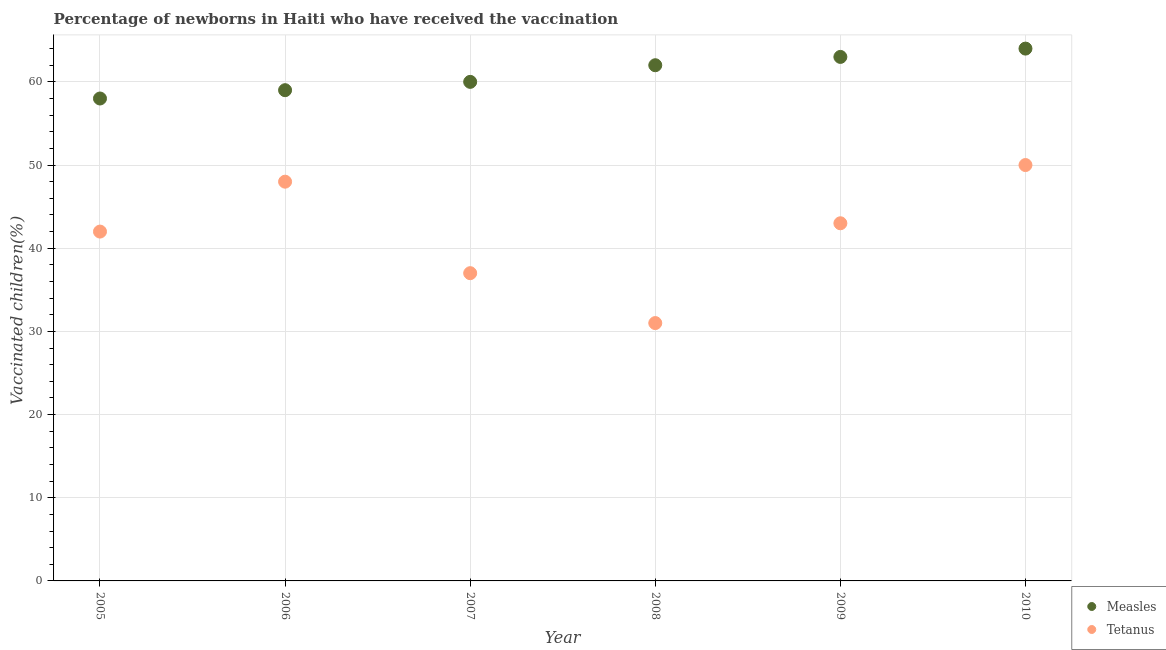How many different coloured dotlines are there?
Provide a short and direct response. 2. What is the percentage of newborns who received vaccination for tetanus in 2009?
Your answer should be very brief. 43. Across all years, what is the maximum percentage of newborns who received vaccination for measles?
Provide a short and direct response. 64. Across all years, what is the minimum percentage of newborns who received vaccination for measles?
Make the answer very short. 58. In which year was the percentage of newborns who received vaccination for measles maximum?
Make the answer very short. 2010. In which year was the percentage of newborns who received vaccination for tetanus minimum?
Offer a very short reply. 2008. What is the total percentage of newborns who received vaccination for tetanus in the graph?
Offer a terse response. 251. What is the difference between the percentage of newborns who received vaccination for measles in 2005 and that in 2009?
Provide a succinct answer. -5. What is the difference between the percentage of newborns who received vaccination for measles in 2010 and the percentage of newborns who received vaccination for tetanus in 2006?
Provide a succinct answer. 16. What is the average percentage of newborns who received vaccination for tetanus per year?
Offer a terse response. 41.83. In the year 2007, what is the difference between the percentage of newborns who received vaccination for tetanus and percentage of newborns who received vaccination for measles?
Offer a very short reply. -23. What is the ratio of the percentage of newborns who received vaccination for measles in 2005 to that in 2008?
Your answer should be very brief. 0.94. Is the percentage of newborns who received vaccination for tetanus in 2007 less than that in 2010?
Your answer should be compact. Yes. What is the difference between the highest and the second highest percentage of newborns who received vaccination for tetanus?
Provide a succinct answer. 2. What is the difference between the highest and the lowest percentage of newborns who received vaccination for tetanus?
Ensure brevity in your answer.  19. In how many years, is the percentage of newborns who received vaccination for tetanus greater than the average percentage of newborns who received vaccination for tetanus taken over all years?
Keep it short and to the point. 4. Is the sum of the percentage of newborns who received vaccination for tetanus in 2006 and 2007 greater than the maximum percentage of newborns who received vaccination for measles across all years?
Offer a terse response. Yes. Is the percentage of newborns who received vaccination for tetanus strictly less than the percentage of newborns who received vaccination for measles over the years?
Provide a succinct answer. Yes. How many dotlines are there?
Your response must be concise. 2. What is the difference between two consecutive major ticks on the Y-axis?
Provide a short and direct response. 10. Are the values on the major ticks of Y-axis written in scientific E-notation?
Provide a succinct answer. No. Does the graph contain grids?
Your answer should be very brief. Yes. How many legend labels are there?
Make the answer very short. 2. How are the legend labels stacked?
Make the answer very short. Vertical. What is the title of the graph?
Make the answer very short. Percentage of newborns in Haiti who have received the vaccination. What is the label or title of the X-axis?
Provide a succinct answer. Year. What is the label or title of the Y-axis?
Make the answer very short. Vaccinated children(%)
. What is the Vaccinated children(%)
 in Measles in 2005?
Give a very brief answer. 58. What is the Vaccinated children(%)
 in Tetanus in 2005?
Your answer should be compact. 42. What is the Vaccinated children(%)
 in Tetanus in 2006?
Your answer should be compact. 48. What is the Vaccinated children(%)
 of Measles in 2007?
Provide a short and direct response. 60. What is the Vaccinated children(%)
 in Tetanus in 2008?
Your answer should be very brief. 31. What is the Vaccinated children(%)
 of Tetanus in 2009?
Your answer should be very brief. 43. What is the Vaccinated children(%)
 of Tetanus in 2010?
Provide a succinct answer. 50. Across all years, what is the maximum Vaccinated children(%)
 in Measles?
Your answer should be compact. 64. What is the total Vaccinated children(%)
 of Measles in the graph?
Your response must be concise. 366. What is the total Vaccinated children(%)
 in Tetanus in the graph?
Keep it short and to the point. 251. What is the difference between the Vaccinated children(%)
 of Measles in 2005 and that in 2007?
Your response must be concise. -2. What is the difference between the Vaccinated children(%)
 in Tetanus in 2005 and that in 2007?
Ensure brevity in your answer.  5. What is the difference between the Vaccinated children(%)
 of Measles in 2005 and that in 2008?
Your answer should be compact. -4. What is the difference between the Vaccinated children(%)
 in Measles in 2005 and that in 2010?
Provide a succinct answer. -6. What is the difference between the Vaccinated children(%)
 in Tetanus in 2005 and that in 2010?
Offer a terse response. -8. What is the difference between the Vaccinated children(%)
 in Measles in 2006 and that in 2008?
Your response must be concise. -3. What is the difference between the Vaccinated children(%)
 in Tetanus in 2006 and that in 2008?
Offer a terse response. 17. What is the difference between the Vaccinated children(%)
 in Measles in 2006 and that in 2009?
Your answer should be compact. -4. What is the difference between the Vaccinated children(%)
 of Tetanus in 2006 and that in 2009?
Your answer should be very brief. 5. What is the difference between the Vaccinated children(%)
 of Measles in 2006 and that in 2010?
Ensure brevity in your answer.  -5. What is the difference between the Vaccinated children(%)
 of Tetanus in 2006 and that in 2010?
Provide a short and direct response. -2. What is the difference between the Vaccinated children(%)
 in Measles in 2007 and that in 2009?
Make the answer very short. -3. What is the difference between the Vaccinated children(%)
 in Tetanus in 2007 and that in 2009?
Provide a short and direct response. -6. What is the difference between the Vaccinated children(%)
 of Tetanus in 2007 and that in 2010?
Make the answer very short. -13. What is the difference between the Vaccinated children(%)
 in Tetanus in 2008 and that in 2010?
Provide a succinct answer. -19. What is the difference between the Vaccinated children(%)
 of Tetanus in 2009 and that in 2010?
Keep it short and to the point. -7. What is the difference between the Vaccinated children(%)
 of Measles in 2005 and the Vaccinated children(%)
 of Tetanus in 2007?
Make the answer very short. 21. What is the difference between the Vaccinated children(%)
 in Measles in 2005 and the Vaccinated children(%)
 in Tetanus in 2008?
Ensure brevity in your answer.  27. What is the difference between the Vaccinated children(%)
 in Measles in 2006 and the Vaccinated children(%)
 in Tetanus in 2007?
Your answer should be very brief. 22. What is the difference between the Vaccinated children(%)
 of Measles in 2007 and the Vaccinated children(%)
 of Tetanus in 2008?
Give a very brief answer. 29. What is the difference between the Vaccinated children(%)
 in Measles in 2007 and the Vaccinated children(%)
 in Tetanus in 2009?
Your answer should be very brief. 17. What is the average Vaccinated children(%)
 of Tetanus per year?
Your answer should be very brief. 41.83. In the year 2006, what is the difference between the Vaccinated children(%)
 in Measles and Vaccinated children(%)
 in Tetanus?
Offer a very short reply. 11. In the year 2007, what is the difference between the Vaccinated children(%)
 of Measles and Vaccinated children(%)
 of Tetanus?
Offer a terse response. 23. What is the ratio of the Vaccinated children(%)
 of Measles in 2005 to that in 2006?
Provide a short and direct response. 0.98. What is the ratio of the Vaccinated children(%)
 in Tetanus in 2005 to that in 2006?
Your answer should be compact. 0.88. What is the ratio of the Vaccinated children(%)
 in Measles in 2005 to that in 2007?
Your answer should be compact. 0.97. What is the ratio of the Vaccinated children(%)
 of Tetanus in 2005 to that in 2007?
Your answer should be compact. 1.14. What is the ratio of the Vaccinated children(%)
 in Measles in 2005 to that in 2008?
Your response must be concise. 0.94. What is the ratio of the Vaccinated children(%)
 of Tetanus in 2005 to that in 2008?
Keep it short and to the point. 1.35. What is the ratio of the Vaccinated children(%)
 in Measles in 2005 to that in 2009?
Provide a succinct answer. 0.92. What is the ratio of the Vaccinated children(%)
 in Tetanus in 2005 to that in 2009?
Give a very brief answer. 0.98. What is the ratio of the Vaccinated children(%)
 in Measles in 2005 to that in 2010?
Offer a terse response. 0.91. What is the ratio of the Vaccinated children(%)
 in Tetanus in 2005 to that in 2010?
Ensure brevity in your answer.  0.84. What is the ratio of the Vaccinated children(%)
 in Measles in 2006 to that in 2007?
Your response must be concise. 0.98. What is the ratio of the Vaccinated children(%)
 of Tetanus in 2006 to that in 2007?
Ensure brevity in your answer.  1.3. What is the ratio of the Vaccinated children(%)
 of Measles in 2006 to that in 2008?
Provide a succinct answer. 0.95. What is the ratio of the Vaccinated children(%)
 of Tetanus in 2006 to that in 2008?
Make the answer very short. 1.55. What is the ratio of the Vaccinated children(%)
 in Measles in 2006 to that in 2009?
Your response must be concise. 0.94. What is the ratio of the Vaccinated children(%)
 in Tetanus in 2006 to that in 2009?
Ensure brevity in your answer.  1.12. What is the ratio of the Vaccinated children(%)
 in Measles in 2006 to that in 2010?
Ensure brevity in your answer.  0.92. What is the ratio of the Vaccinated children(%)
 in Tetanus in 2006 to that in 2010?
Keep it short and to the point. 0.96. What is the ratio of the Vaccinated children(%)
 in Measles in 2007 to that in 2008?
Keep it short and to the point. 0.97. What is the ratio of the Vaccinated children(%)
 in Tetanus in 2007 to that in 2008?
Your answer should be compact. 1.19. What is the ratio of the Vaccinated children(%)
 of Tetanus in 2007 to that in 2009?
Ensure brevity in your answer.  0.86. What is the ratio of the Vaccinated children(%)
 of Measles in 2007 to that in 2010?
Give a very brief answer. 0.94. What is the ratio of the Vaccinated children(%)
 in Tetanus in 2007 to that in 2010?
Provide a succinct answer. 0.74. What is the ratio of the Vaccinated children(%)
 in Measles in 2008 to that in 2009?
Keep it short and to the point. 0.98. What is the ratio of the Vaccinated children(%)
 in Tetanus in 2008 to that in 2009?
Your answer should be compact. 0.72. What is the ratio of the Vaccinated children(%)
 of Measles in 2008 to that in 2010?
Provide a short and direct response. 0.97. What is the ratio of the Vaccinated children(%)
 of Tetanus in 2008 to that in 2010?
Ensure brevity in your answer.  0.62. What is the ratio of the Vaccinated children(%)
 of Measles in 2009 to that in 2010?
Your answer should be compact. 0.98. What is the ratio of the Vaccinated children(%)
 in Tetanus in 2009 to that in 2010?
Keep it short and to the point. 0.86. What is the difference between the highest and the second highest Vaccinated children(%)
 in Measles?
Your answer should be very brief. 1. What is the difference between the highest and the second highest Vaccinated children(%)
 in Tetanus?
Provide a succinct answer. 2. What is the difference between the highest and the lowest Vaccinated children(%)
 in Measles?
Your response must be concise. 6. 